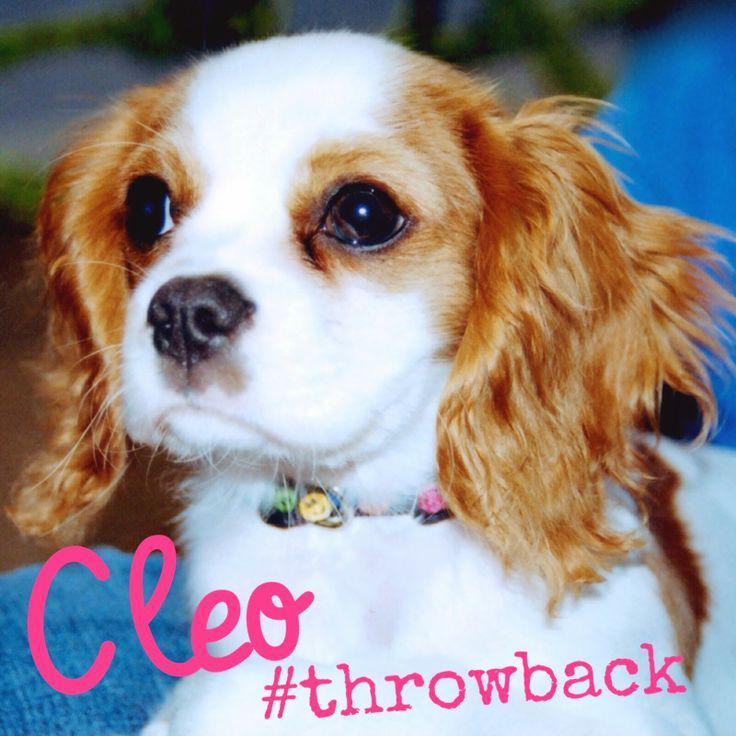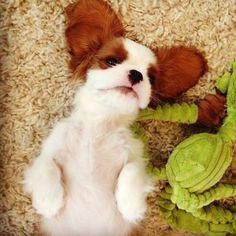The first image is the image on the left, the second image is the image on the right. For the images shown, is this caption "One of the brown and white dogs has a toy." true? Answer yes or no. Yes. The first image is the image on the left, the second image is the image on the right. For the images displayed, is the sentence "All the dogs are looking straight ahead." factually correct? Answer yes or no. No. 